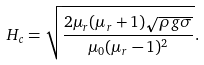<formula> <loc_0><loc_0><loc_500><loc_500>H _ { c } = \sqrt { \frac { 2 \mu _ { r } ( \mu _ { r } + 1 ) \sqrt { \rho g \sigma } } { \mu _ { 0 } ( \mu _ { r } - 1 ) ^ { 2 } } } .</formula> 